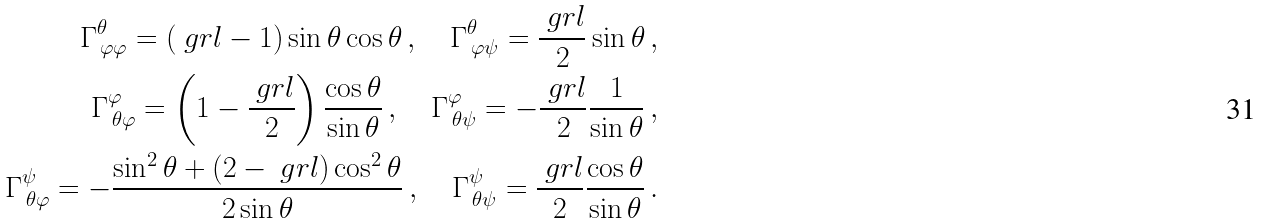<formula> <loc_0><loc_0><loc_500><loc_500>\Gamma ^ { \theta } _ { \, \varphi \varphi } = ( \ g r l - 1 ) \sin \theta \cos \theta \, , \quad \Gamma ^ { \theta } _ { \, \varphi \psi } = \frac { \ g r l } { 2 } \sin \theta \, , \\ \Gamma ^ { \varphi } _ { \, \theta \varphi } = \left ( 1 - \frac { \ g r l } { 2 } \right ) \frac { \cos \theta } { \sin \theta } \, , \quad \Gamma ^ { \varphi } _ { \, \theta \psi } = - \frac { \ g r l } { 2 } \frac { 1 } { \sin \theta } \, , \\ \Gamma ^ { \psi } _ { \, \theta \varphi } = - \frac { \sin ^ { 2 } \theta + ( 2 - \ g r l ) \cos ^ { 2 } \theta } { 2 \sin \theta } \, , \quad \Gamma ^ { \psi } _ { \, \theta \psi } = \frac { \ g r l } { 2 } \frac { \cos \theta } { \sin \theta } \, .</formula> 